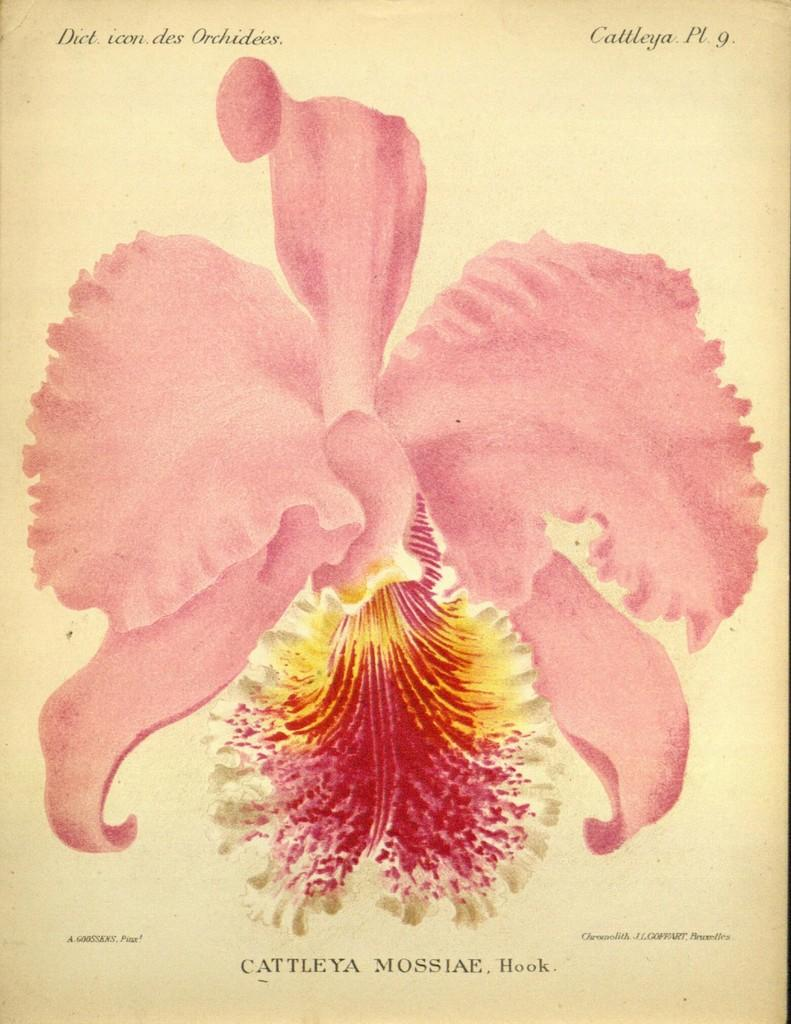What is depicted on the paper in the image? There is a picture of a flower on a paper in the image. Where is the best place for the flower to sleep in the image? The image does not depict a living flower, nor does it show any place for a flower to sleep. 